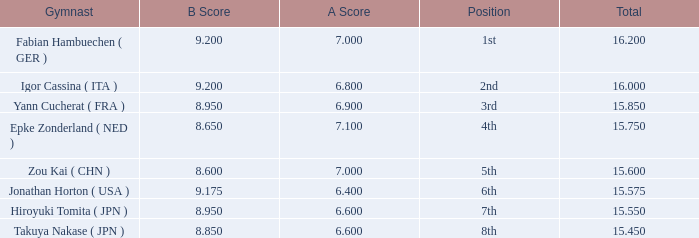Which gymnast had a b score of 8.95 and an a score less than 6.9 Hiroyuki Tomita ( JPN ). 